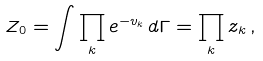<formula> <loc_0><loc_0><loc_500><loc_500>Z _ { 0 } = \int \prod _ { k } e ^ { - v _ { k } } \, d \Gamma = \prod _ { k } z _ { k } \, ,</formula> 